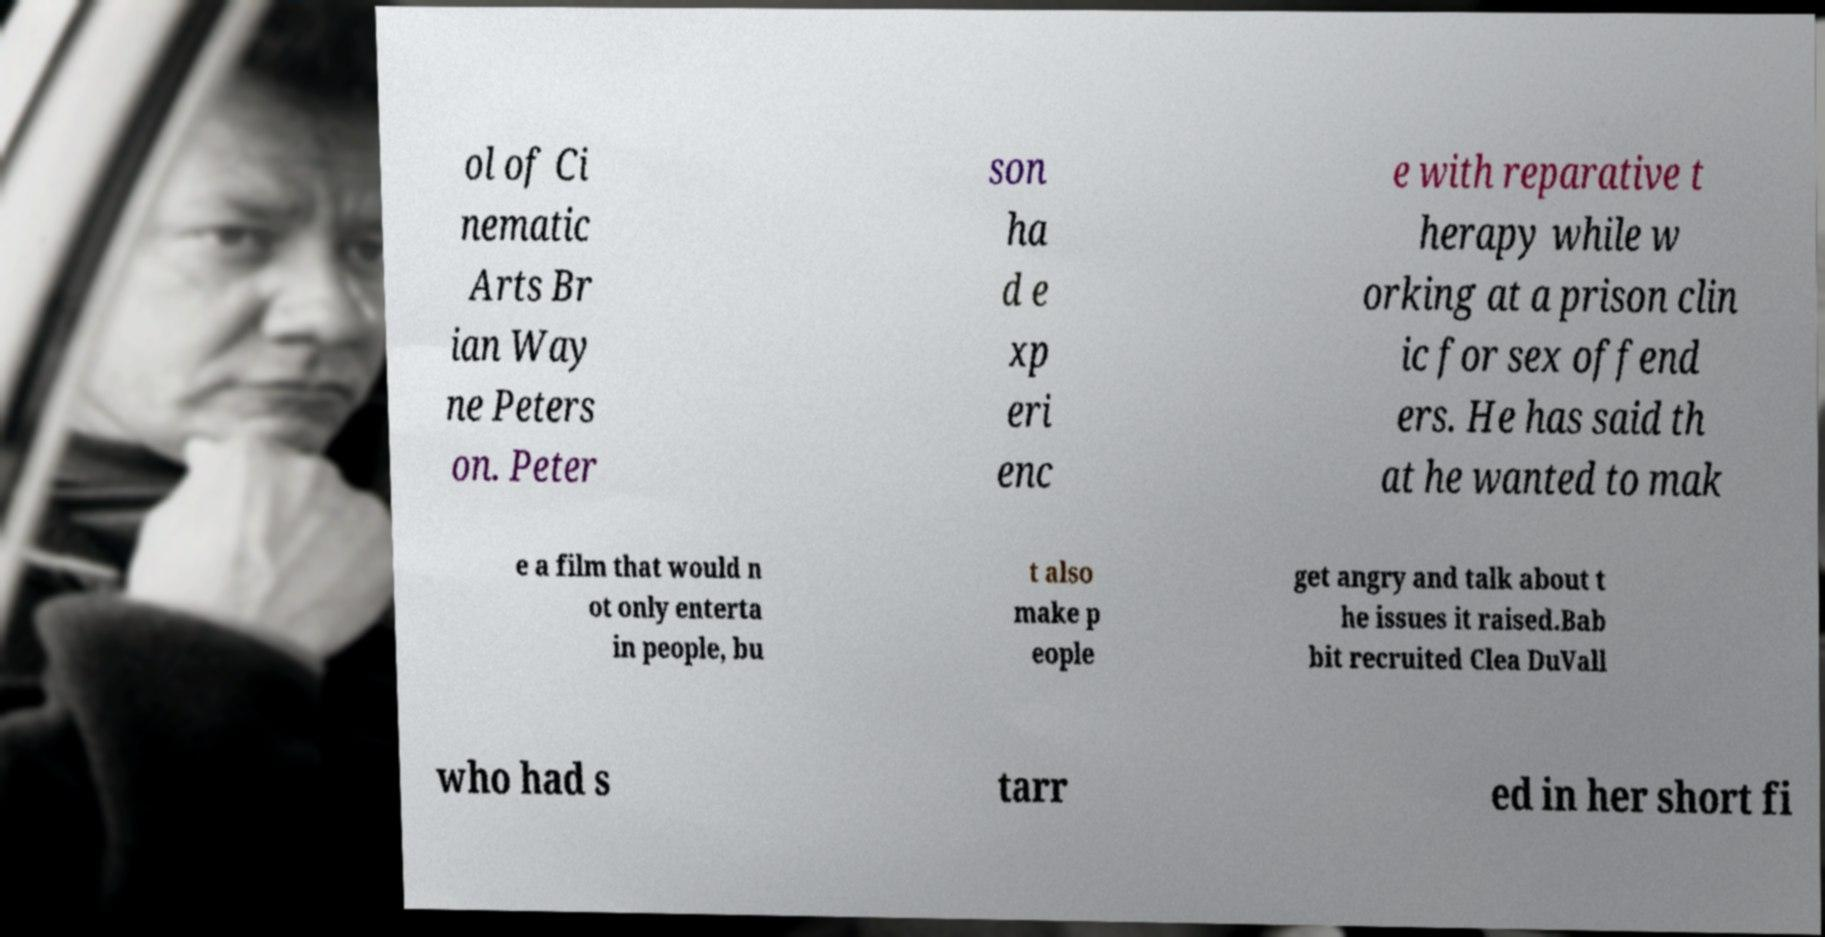Can you read and provide the text displayed in the image?This photo seems to have some interesting text. Can you extract and type it out for me? ol of Ci nematic Arts Br ian Way ne Peters on. Peter son ha d e xp eri enc e with reparative t herapy while w orking at a prison clin ic for sex offend ers. He has said th at he wanted to mak e a film that would n ot only enterta in people, bu t also make p eople get angry and talk about t he issues it raised.Bab bit recruited Clea DuVall who had s tarr ed in her short fi 